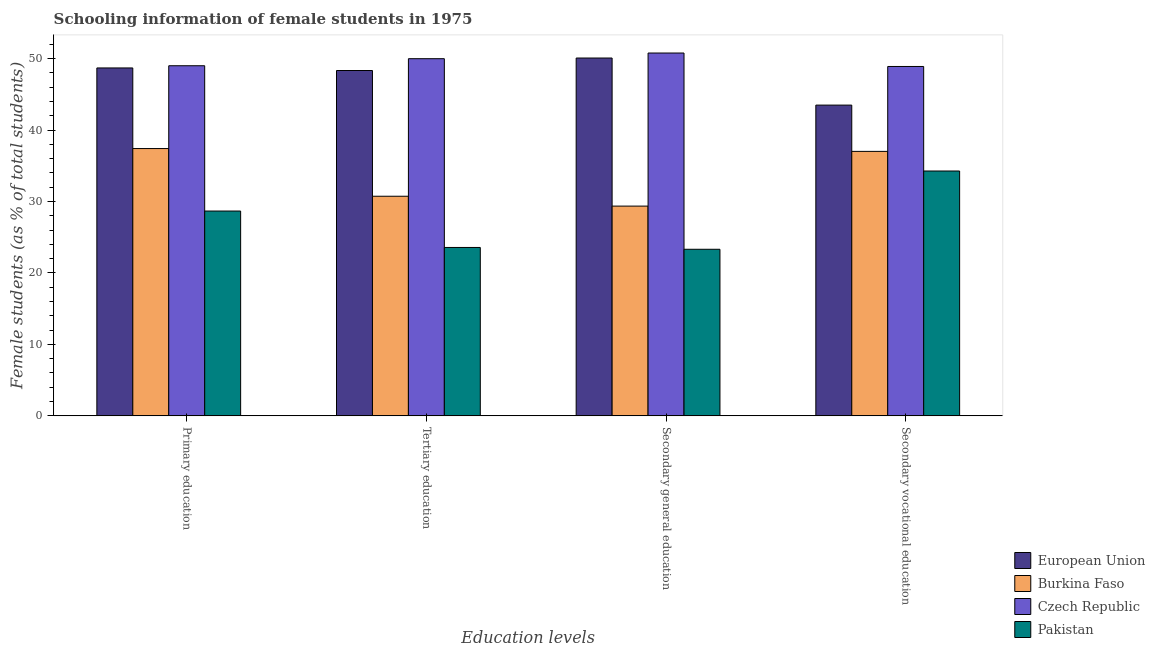How many different coloured bars are there?
Offer a terse response. 4. How many groups of bars are there?
Your answer should be compact. 4. How many bars are there on the 2nd tick from the left?
Provide a short and direct response. 4. How many bars are there on the 1st tick from the right?
Offer a very short reply. 4. What is the label of the 3rd group of bars from the left?
Give a very brief answer. Secondary general education. What is the percentage of female students in secondary education in European Union?
Provide a succinct answer. 50.08. Across all countries, what is the maximum percentage of female students in tertiary education?
Offer a very short reply. 49.99. Across all countries, what is the minimum percentage of female students in secondary vocational education?
Your answer should be compact. 34.27. In which country was the percentage of female students in secondary vocational education maximum?
Make the answer very short. Czech Republic. In which country was the percentage of female students in secondary vocational education minimum?
Your response must be concise. Pakistan. What is the total percentage of female students in secondary vocational education in the graph?
Ensure brevity in your answer.  163.68. What is the difference between the percentage of female students in tertiary education in Pakistan and that in European Union?
Ensure brevity in your answer.  -24.76. What is the difference between the percentage of female students in tertiary education in European Union and the percentage of female students in secondary vocational education in Pakistan?
Give a very brief answer. 14.06. What is the average percentage of female students in primary education per country?
Your response must be concise. 40.94. What is the difference between the percentage of female students in secondary vocational education and percentage of female students in secondary education in Burkina Faso?
Make the answer very short. 7.66. In how many countries, is the percentage of female students in primary education greater than 12 %?
Your answer should be compact. 4. What is the ratio of the percentage of female students in secondary education in Pakistan to that in European Union?
Offer a very short reply. 0.47. What is the difference between the highest and the second highest percentage of female students in tertiary education?
Give a very brief answer. 1.65. What is the difference between the highest and the lowest percentage of female students in primary education?
Offer a very short reply. 20.33. In how many countries, is the percentage of female students in primary education greater than the average percentage of female students in primary education taken over all countries?
Ensure brevity in your answer.  2. What does the 1st bar from the left in Tertiary education represents?
Your response must be concise. European Union. What does the 3rd bar from the right in Secondary vocational education represents?
Your answer should be very brief. Burkina Faso. How many countries are there in the graph?
Keep it short and to the point. 4. What is the difference between two consecutive major ticks on the Y-axis?
Provide a succinct answer. 10. Does the graph contain any zero values?
Offer a very short reply. No. What is the title of the graph?
Your response must be concise. Schooling information of female students in 1975. Does "Sweden" appear as one of the legend labels in the graph?
Keep it short and to the point. No. What is the label or title of the X-axis?
Offer a terse response. Education levels. What is the label or title of the Y-axis?
Give a very brief answer. Female students (as % of total students). What is the Female students (as % of total students) in European Union in Primary education?
Ensure brevity in your answer.  48.69. What is the Female students (as % of total students) in Burkina Faso in Primary education?
Your answer should be very brief. 37.41. What is the Female students (as % of total students) in Czech Republic in Primary education?
Provide a short and direct response. 49. What is the Female students (as % of total students) of Pakistan in Primary education?
Offer a very short reply. 28.67. What is the Female students (as % of total students) in European Union in Tertiary education?
Offer a terse response. 48.33. What is the Female students (as % of total students) in Burkina Faso in Tertiary education?
Provide a succinct answer. 30.74. What is the Female students (as % of total students) of Czech Republic in Tertiary education?
Offer a terse response. 49.99. What is the Female students (as % of total students) in Pakistan in Tertiary education?
Ensure brevity in your answer.  23.57. What is the Female students (as % of total students) in European Union in Secondary general education?
Ensure brevity in your answer.  50.08. What is the Female students (as % of total students) of Burkina Faso in Secondary general education?
Offer a very short reply. 29.36. What is the Female students (as % of total students) in Czech Republic in Secondary general education?
Offer a very short reply. 50.78. What is the Female students (as % of total students) in Pakistan in Secondary general education?
Your answer should be compact. 23.31. What is the Female students (as % of total students) of European Union in Secondary vocational education?
Your answer should be very brief. 43.49. What is the Female students (as % of total students) in Burkina Faso in Secondary vocational education?
Make the answer very short. 37.02. What is the Female students (as % of total students) in Czech Republic in Secondary vocational education?
Ensure brevity in your answer.  48.9. What is the Female students (as % of total students) of Pakistan in Secondary vocational education?
Make the answer very short. 34.27. Across all Education levels, what is the maximum Female students (as % of total students) of European Union?
Your answer should be compact. 50.08. Across all Education levels, what is the maximum Female students (as % of total students) of Burkina Faso?
Your answer should be compact. 37.41. Across all Education levels, what is the maximum Female students (as % of total students) of Czech Republic?
Provide a short and direct response. 50.78. Across all Education levels, what is the maximum Female students (as % of total students) in Pakistan?
Your answer should be very brief. 34.27. Across all Education levels, what is the minimum Female students (as % of total students) of European Union?
Ensure brevity in your answer.  43.49. Across all Education levels, what is the minimum Female students (as % of total students) of Burkina Faso?
Provide a succinct answer. 29.36. Across all Education levels, what is the minimum Female students (as % of total students) in Czech Republic?
Your answer should be compact. 48.9. Across all Education levels, what is the minimum Female students (as % of total students) of Pakistan?
Make the answer very short. 23.31. What is the total Female students (as % of total students) in European Union in the graph?
Provide a short and direct response. 190.6. What is the total Female students (as % of total students) of Burkina Faso in the graph?
Your answer should be very brief. 134.52. What is the total Female students (as % of total students) of Czech Republic in the graph?
Your response must be concise. 198.67. What is the total Female students (as % of total students) in Pakistan in the graph?
Provide a succinct answer. 109.82. What is the difference between the Female students (as % of total students) of European Union in Primary education and that in Tertiary education?
Ensure brevity in your answer.  0.36. What is the difference between the Female students (as % of total students) of Burkina Faso in Primary education and that in Tertiary education?
Provide a short and direct response. 6.67. What is the difference between the Female students (as % of total students) of Czech Republic in Primary education and that in Tertiary education?
Your response must be concise. -0.99. What is the difference between the Female students (as % of total students) of Pakistan in Primary education and that in Tertiary education?
Provide a succinct answer. 5.1. What is the difference between the Female students (as % of total students) in European Union in Primary education and that in Secondary general education?
Make the answer very short. -1.39. What is the difference between the Female students (as % of total students) of Burkina Faso in Primary education and that in Secondary general education?
Provide a succinct answer. 8.05. What is the difference between the Female students (as % of total students) in Czech Republic in Primary education and that in Secondary general education?
Give a very brief answer. -1.78. What is the difference between the Female students (as % of total students) of Pakistan in Primary education and that in Secondary general education?
Offer a very short reply. 5.35. What is the difference between the Female students (as % of total students) in European Union in Primary education and that in Secondary vocational education?
Offer a very short reply. 5.2. What is the difference between the Female students (as % of total students) in Burkina Faso in Primary education and that in Secondary vocational education?
Your answer should be compact. 0.4. What is the difference between the Female students (as % of total students) in Czech Republic in Primary education and that in Secondary vocational education?
Provide a short and direct response. 0.1. What is the difference between the Female students (as % of total students) in Pakistan in Primary education and that in Secondary vocational education?
Give a very brief answer. -5.6. What is the difference between the Female students (as % of total students) in European Union in Tertiary education and that in Secondary general education?
Offer a very short reply. -1.75. What is the difference between the Female students (as % of total students) in Burkina Faso in Tertiary education and that in Secondary general education?
Offer a very short reply. 1.38. What is the difference between the Female students (as % of total students) of Czech Republic in Tertiary education and that in Secondary general education?
Your response must be concise. -0.79. What is the difference between the Female students (as % of total students) of Pakistan in Tertiary education and that in Secondary general education?
Provide a succinct answer. 0.25. What is the difference between the Female students (as % of total students) of European Union in Tertiary education and that in Secondary vocational education?
Your answer should be compact. 4.84. What is the difference between the Female students (as % of total students) in Burkina Faso in Tertiary education and that in Secondary vocational education?
Provide a succinct answer. -6.28. What is the difference between the Female students (as % of total students) of Czech Republic in Tertiary education and that in Secondary vocational education?
Your answer should be very brief. 1.09. What is the difference between the Female students (as % of total students) of Pakistan in Tertiary education and that in Secondary vocational education?
Keep it short and to the point. -10.7. What is the difference between the Female students (as % of total students) in European Union in Secondary general education and that in Secondary vocational education?
Provide a succinct answer. 6.59. What is the difference between the Female students (as % of total students) of Burkina Faso in Secondary general education and that in Secondary vocational education?
Ensure brevity in your answer.  -7.66. What is the difference between the Female students (as % of total students) of Czech Republic in Secondary general education and that in Secondary vocational education?
Offer a very short reply. 1.88. What is the difference between the Female students (as % of total students) of Pakistan in Secondary general education and that in Secondary vocational education?
Offer a terse response. -10.95. What is the difference between the Female students (as % of total students) of European Union in Primary education and the Female students (as % of total students) of Burkina Faso in Tertiary education?
Ensure brevity in your answer.  17.96. What is the difference between the Female students (as % of total students) in European Union in Primary education and the Female students (as % of total students) in Czech Republic in Tertiary education?
Provide a short and direct response. -1.29. What is the difference between the Female students (as % of total students) in European Union in Primary education and the Female students (as % of total students) in Pakistan in Tertiary education?
Offer a very short reply. 25.12. What is the difference between the Female students (as % of total students) in Burkina Faso in Primary education and the Female students (as % of total students) in Czech Republic in Tertiary education?
Your answer should be very brief. -12.58. What is the difference between the Female students (as % of total students) in Burkina Faso in Primary education and the Female students (as % of total students) in Pakistan in Tertiary education?
Make the answer very short. 13.84. What is the difference between the Female students (as % of total students) of Czech Republic in Primary education and the Female students (as % of total students) of Pakistan in Tertiary education?
Keep it short and to the point. 25.43. What is the difference between the Female students (as % of total students) of European Union in Primary education and the Female students (as % of total students) of Burkina Faso in Secondary general education?
Make the answer very short. 19.34. What is the difference between the Female students (as % of total students) of European Union in Primary education and the Female students (as % of total students) of Czech Republic in Secondary general education?
Ensure brevity in your answer.  -2.09. What is the difference between the Female students (as % of total students) of European Union in Primary education and the Female students (as % of total students) of Pakistan in Secondary general education?
Your answer should be compact. 25.38. What is the difference between the Female students (as % of total students) in Burkina Faso in Primary education and the Female students (as % of total students) in Czech Republic in Secondary general education?
Offer a terse response. -13.37. What is the difference between the Female students (as % of total students) in Burkina Faso in Primary education and the Female students (as % of total students) in Pakistan in Secondary general education?
Your answer should be very brief. 14.1. What is the difference between the Female students (as % of total students) of Czech Republic in Primary education and the Female students (as % of total students) of Pakistan in Secondary general education?
Offer a terse response. 25.69. What is the difference between the Female students (as % of total students) of European Union in Primary education and the Female students (as % of total students) of Burkina Faso in Secondary vocational education?
Provide a short and direct response. 11.68. What is the difference between the Female students (as % of total students) of European Union in Primary education and the Female students (as % of total students) of Czech Republic in Secondary vocational education?
Give a very brief answer. -0.2. What is the difference between the Female students (as % of total students) in European Union in Primary education and the Female students (as % of total students) in Pakistan in Secondary vocational education?
Offer a terse response. 14.42. What is the difference between the Female students (as % of total students) of Burkina Faso in Primary education and the Female students (as % of total students) of Czech Republic in Secondary vocational education?
Make the answer very short. -11.49. What is the difference between the Female students (as % of total students) of Burkina Faso in Primary education and the Female students (as % of total students) of Pakistan in Secondary vocational education?
Offer a terse response. 3.14. What is the difference between the Female students (as % of total students) of Czech Republic in Primary education and the Female students (as % of total students) of Pakistan in Secondary vocational education?
Make the answer very short. 14.73. What is the difference between the Female students (as % of total students) of European Union in Tertiary education and the Female students (as % of total students) of Burkina Faso in Secondary general education?
Ensure brevity in your answer.  18.98. What is the difference between the Female students (as % of total students) in European Union in Tertiary education and the Female students (as % of total students) in Czech Republic in Secondary general education?
Provide a succinct answer. -2.45. What is the difference between the Female students (as % of total students) in European Union in Tertiary education and the Female students (as % of total students) in Pakistan in Secondary general education?
Your response must be concise. 25.02. What is the difference between the Female students (as % of total students) in Burkina Faso in Tertiary education and the Female students (as % of total students) in Czech Republic in Secondary general education?
Your answer should be compact. -20.05. What is the difference between the Female students (as % of total students) in Burkina Faso in Tertiary education and the Female students (as % of total students) in Pakistan in Secondary general education?
Your response must be concise. 7.42. What is the difference between the Female students (as % of total students) in Czech Republic in Tertiary education and the Female students (as % of total students) in Pakistan in Secondary general education?
Give a very brief answer. 26.67. What is the difference between the Female students (as % of total students) in European Union in Tertiary education and the Female students (as % of total students) in Burkina Faso in Secondary vocational education?
Your answer should be very brief. 11.32. What is the difference between the Female students (as % of total students) of European Union in Tertiary education and the Female students (as % of total students) of Czech Republic in Secondary vocational education?
Offer a very short reply. -0.56. What is the difference between the Female students (as % of total students) of European Union in Tertiary education and the Female students (as % of total students) of Pakistan in Secondary vocational education?
Your response must be concise. 14.06. What is the difference between the Female students (as % of total students) in Burkina Faso in Tertiary education and the Female students (as % of total students) in Czech Republic in Secondary vocational education?
Offer a terse response. -18.16. What is the difference between the Female students (as % of total students) of Burkina Faso in Tertiary education and the Female students (as % of total students) of Pakistan in Secondary vocational education?
Give a very brief answer. -3.53. What is the difference between the Female students (as % of total students) of Czech Republic in Tertiary education and the Female students (as % of total students) of Pakistan in Secondary vocational education?
Your response must be concise. 15.72. What is the difference between the Female students (as % of total students) in European Union in Secondary general education and the Female students (as % of total students) in Burkina Faso in Secondary vocational education?
Your answer should be very brief. 13.06. What is the difference between the Female students (as % of total students) in European Union in Secondary general education and the Female students (as % of total students) in Czech Republic in Secondary vocational education?
Make the answer very short. 1.18. What is the difference between the Female students (as % of total students) in European Union in Secondary general education and the Female students (as % of total students) in Pakistan in Secondary vocational education?
Offer a terse response. 15.81. What is the difference between the Female students (as % of total students) of Burkina Faso in Secondary general education and the Female students (as % of total students) of Czech Republic in Secondary vocational education?
Your response must be concise. -19.54. What is the difference between the Female students (as % of total students) of Burkina Faso in Secondary general education and the Female students (as % of total students) of Pakistan in Secondary vocational education?
Give a very brief answer. -4.91. What is the difference between the Female students (as % of total students) of Czech Republic in Secondary general education and the Female students (as % of total students) of Pakistan in Secondary vocational education?
Your response must be concise. 16.51. What is the average Female students (as % of total students) in European Union per Education levels?
Offer a very short reply. 47.65. What is the average Female students (as % of total students) of Burkina Faso per Education levels?
Your response must be concise. 33.63. What is the average Female students (as % of total students) of Czech Republic per Education levels?
Your response must be concise. 49.67. What is the average Female students (as % of total students) of Pakistan per Education levels?
Your answer should be compact. 27.45. What is the difference between the Female students (as % of total students) of European Union and Female students (as % of total students) of Burkina Faso in Primary education?
Offer a terse response. 11.28. What is the difference between the Female students (as % of total students) of European Union and Female students (as % of total students) of Czech Republic in Primary education?
Provide a short and direct response. -0.31. What is the difference between the Female students (as % of total students) in European Union and Female students (as % of total students) in Pakistan in Primary education?
Ensure brevity in your answer.  20.03. What is the difference between the Female students (as % of total students) in Burkina Faso and Female students (as % of total students) in Czech Republic in Primary education?
Provide a succinct answer. -11.59. What is the difference between the Female students (as % of total students) of Burkina Faso and Female students (as % of total students) of Pakistan in Primary education?
Provide a succinct answer. 8.74. What is the difference between the Female students (as % of total students) in Czech Republic and Female students (as % of total students) in Pakistan in Primary education?
Offer a terse response. 20.33. What is the difference between the Female students (as % of total students) of European Union and Female students (as % of total students) of Burkina Faso in Tertiary education?
Your answer should be compact. 17.6. What is the difference between the Female students (as % of total students) of European Union and Female students (as % of total students) of Czech Republic in Tertiary education?
Make the answer very short. -1.65. What is the difference between the Female students (as % of total students) in European Union and Female students (as % of total students) in Pakistan in Tertiary education?
Offer a terse response. 24.76. What is the difference between the Female students (as % of total students) in Burkina Faso and Female students (as % of total students) in Czech Republic in Tertiary education?
Keep it short and to the point. -19.25. What is the difference between the Female students (as % of total students) in Burkina Faso and Female students (as % of total students) in Pakistan in Tertiary education?
Provide a succinct answer. 7.17. What is the difference between the Female students (as % of total students) of Czech Republic and Female students (as % of total students) of Pakistan in Tertiary education?
Keep it short and to the point. 26.42. What is the difference between the Female students (as % of total students) in European Union and Female students (as % of total students) in Burkina Faso in Secondary general education?
Provide a succinct answer. 20.72. What is the difference between the Female students (as % of total students) of European Union and Female students (as % of total students) of Czech Republic in Secondary general education?
Offer a terse response. -0.7. What is the difference between the Female students (as % of total students) in European Union and Female students (as % of total students) in Pakistan in Secondary general education?
Provide a short and direct response. 26.77. What is the difference between the Female students (as % of total students) of Burkina Faso and Female students (as % of total students) of Czech Republic in Secondary general education?
Ensure brevity in your answer.  -21.43. What is the difference between the Female students (as % of total students) of Burkina Faso and Female students (as % of total students) of Pakistan in Secondary general education?
Make the answer very short. 6.04. What is the difference between the Female students (as % of total students) in Czech Republic and Female students (as % of total students) in Pakistan in Secondary general education?
Keep it short and to the point. 27.47. What is the difference between the Female students (as % of total students) in European Union and Female students (as % of total students) in Burkina Faso in Secondary vocational education?
Your answer should be compact. 6.48. What is the difference between the Female students (as % of total students) of European Union and Female students (as % of total students) of Czech Republic in Secondary vocational education?
Keep it short and to the point. -5.41. What is the difference between the Female students (as % of total students) of European Union and Female students (as % of total students) of Pakistan in Secondary vocational education?
Your response must be concise. 9.22. What is the difference between the Female students (as % of total students) in Burkina Faso and Female students (as % of total students) in Czech Republic in Secondary vocational education?
Offer a terse response. -11.88. What is the difference between the Female students (as % of total students) in Burkina Faso and Female students (as % of total students) in Pakistan in Secondary vocational education?
Your answer should be very brief. 2.75. What is the difference between the Female students (as % of total students) of Czech Republic and Female students (as % of total students) of Pakistan in Secondary vocational education?
Offer a very short reply. 14.63. What is the ratio of the Female students (as % of total students) in European Union in Primary education to that in Tertiary education?
Offer a terse response. 1.01. What is the ratio of the Female students (as % of total students) of Burkina Faso in Primary education to that in Tertiary education?
Offer a terse response. 1.22. What is the ratio of the Female students (as % of total students) in Czech Republic in Primary education to that in Tertiary education?
Keep it short and to the point. 0.98. What is the ratio of the Female students (as % of total students) in Pakistan in Primary education to that in Tertiary education?
Provide a short and direct response. 1.22. What is the ratio of the Female students (as % of total students) in European Union in Primary education to that in Secondary general education?
Make the answer very short. 0.97. What is the ratio of the Female students (as % of total students) in Burkina Faso in Primary education to that in Secondary general education?
Offer a terse response. 1.27. What is the ratio of the Female students (as % of total students) in Czech Republic in Primary education to that in Secondary general education?
Make the answer very short. 0.96. What is the ratio of the Female students (as % of total students) of Pakistan in Primary education to that in Secondary general education?
Offer a very short reply. 1.23. What is the ratio of the Female students (as % of total students) in European Union in Primary education to that in Secondary vocational education?
Offer a terse response. 1.12. What is the ratio of the Female students (as % of total students) of Burkina Faso in Primary education to that in Secondary vocational education?
Offer a terse response. 1.01. What is the ratio of the Female students (as % of total students) in Pakistan in Primary education to that in Secondary vocational education?
Make the answer very short. 0.84. What is the ratio of the Female students (as % of total students) in European Union in Tertiary education to that in Secondary general education?
Offer a very short reply. 0.97. What is the ratio of the Female students (as % of total students) of Burkina Faso in Tertiary education to that in Secondary general education?
Offer a very short reply. 1.05. What is the ratio of the Female students (as % of total students) in Czech Republic in Tertiary education to that in Secondary general education?
Your answer should be compact. 0.98. What is the ratio of the Female students (as % of total students) of Pakistan in Tertiary education to that in Secondary general education?
Your answer should be compact. 1.01. What is the ratio of the Female students (as % of total students) in European Union in Tertiary education to that in Secondary vocational education?
Your response must be concise. 1.11. What is the ratio of the Female students (as % of total students) of Burkina Faso in Tertiary education to that in Secondary vocational education?
Provide a short and direct response. 0.83. What is the ratio of the Female students (as % of total students) of Czech Republic in Tertiary education to that in Secondary vocational education?
Give a very brief answer. 1.02. What is the ratio of the Female students (as % of total students) in Pakistan in Tertiary education to that in Secondary vocational education?
Provide a short and direct response. 0.69. What is the ratio of the Female students (as % of total students) of European Union in Secondary general education to that in Secondary vocational education?
Your response must be concise. 1.15. What is the ratio of the Female students (as % of total students) in Burkina Faso in Secondary general education to that in Secondary vocational education?
Keep it short and to the point. 0.79. What is the ratio of the Female students (as % of total students) of Pakistan in Secondary general education to that in Secondary vocational education?
Offer a terse response. 0.68. What is the difference between the highest and the second highest Female students (as % of total students) in European Union?
Your answer should be very brief. 1.39. What is the difference between the highest and the second highest Female students (as % of total students) in Burkina Faso?
Offer a very short reply. 0.4. What is the difference between the highest and the second highest Female students (as % of total students) of Czech Republic?
Give a very brief answer. 0.79. What is the difference between the highest and the second highest Female students (as % of total students) of Pakistan?
Your answer should be compact. 5.6. What is the difference between the highest and the lowest Female students (as % of total students) of European Union?
Provide a succinct answer. 6.59. What is the difference between the highest and the lowest Female students (as % of total students) of Burkina Faso?
Provide a short and direct response. 8.05. What is the difference between the highest and the lowest Female students (as % of total students) in Czech Republic?
Make the answer very short. 1.88. What is the difference between the highest and the lowest Female students (as % of total students) of Pakistan?
Your response must be concise. 10.95. 